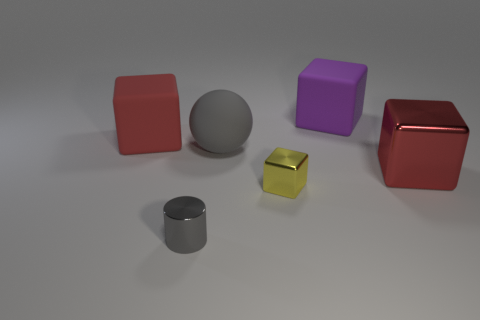Add 1 red matte blocks. How many objects exist? 7 Subtract all spheres. How many objects are left? 5 Subtract 0 cyan spheres. How many objects are left? 6 Subtract all large yellow balls. Subtract all metal cylinders. How many objects are left? 5 Add 1 cubes. How many cubes are left? 5 Add 6 yellow objects. How many yellow objects exist? 7 